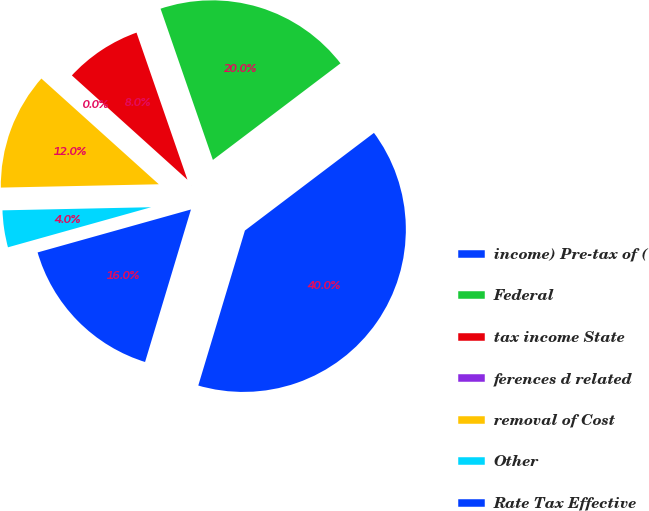Convert chart to OTSL. <chart><loc_0><loc_0><loc_500><loc_500><pie_chart><fcel>income) Pre-tax of (<fcel>Federal<fcel>tax income State<fcel>ferences d related<fcel>removal of Cost<fcel>Other<fcel>Rate Tax Effective<nl><fcel>39.96%<fcel>19.99%<fcel>8.01%<fcel>0.02%<fcel>12.0%<fcel>4.01%<fcel>16.0%<nl></chart> 